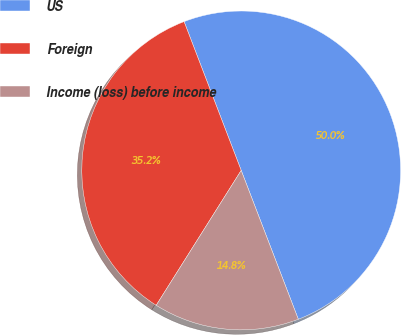Convert chart. <chart><loc_0><loc_0><loc_500><loc_500><pie_chart><fcel>US<fcel>Foreign<fcel>Income (loss) before income<nl><fcel>50.0%<fcel>35.22%<fcel>14.78%<nl></chart> 